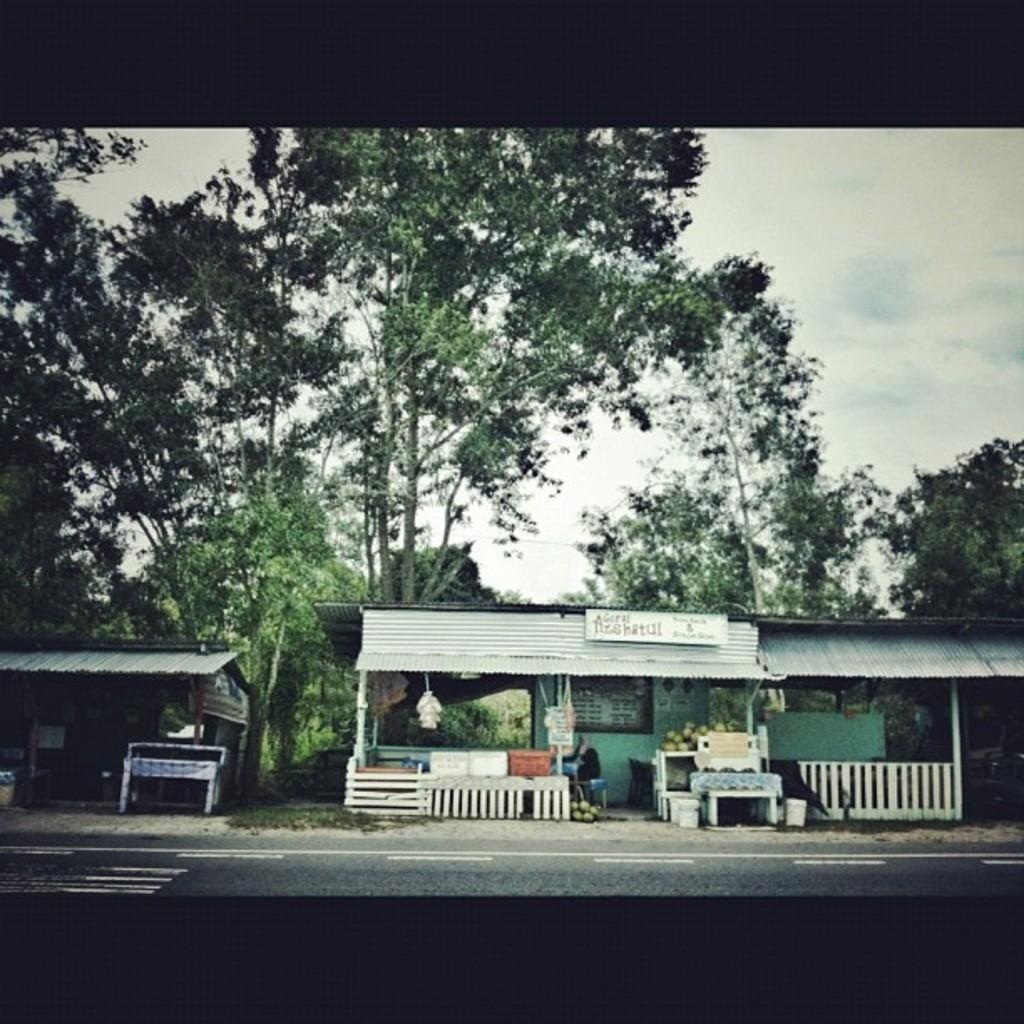What is in the foreground of the image? There is a road in the foreground of the image. What can be seen in the middle of the image? There are small shops, tables, a board, trees, and various objects in the middle of the image. What is visible in the background of the image? The sky is visible in the background of the image. What type of insurance is being sold at the small shops in the image? There is no indication of insurance being sold or discussed in the image. What kind of seed is being used to grow the trees in the image? The image does not provide information about the type of seed used to grow the trees. 